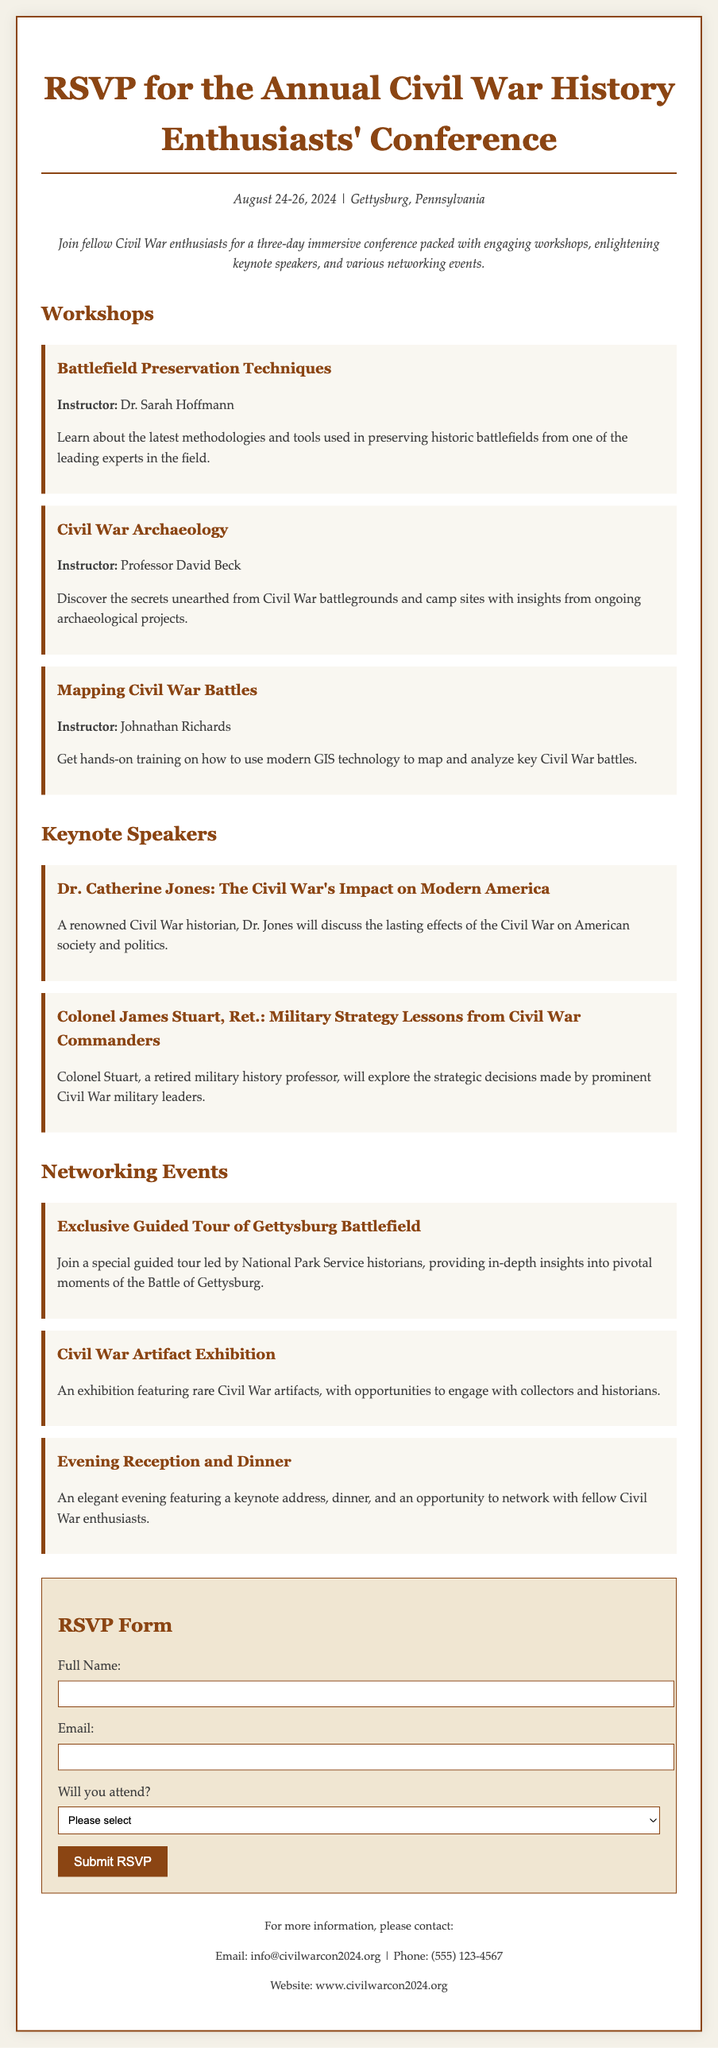What are the dates of the conference? The dates of the conference are clearly mentioned in the introduction section.
Answer: August 24-26, 2024 Who is the instructor for the "Civil War Archaeology" workshop? The instructor's name is specified in the description of the workshop.
Answer: Professor David Beck What is the title of Dr. Catherine Jones' keynote address? The title of her keynote address is listed alongside her name in the Keynote Speakers section.
Answer: The Civil War's Impact on Modern America What type of event is the "Evening Reception and Dinner"? This is categorized under Networking Events, which provides information about the event type.
Answer: Networking Event How many workshops are listed in the document? The total number of workshops can be counted from the Workshops section headers.
Answer: Three Why might someone be interested in the "Exclusive Guided Tour of Gettysburg Battlefield"? This question requires reasoning about the value of the provided event, which is known for its significance.
Answer: In-depth insights into pivotal moments What email address can inquiries be sent to? The email address for more information is found in the contact section at the end of the document.
Answer: info@civilwarcon2024.org What is the main theme of the conference? The main theme can be inferred from the overall context and focus of the activities mentioned.
Answer: Civil War history Will there be opportunities for networking at the conference? The presence of networking-related events indicates engagement opportunities among participants.
Answer: Yes 